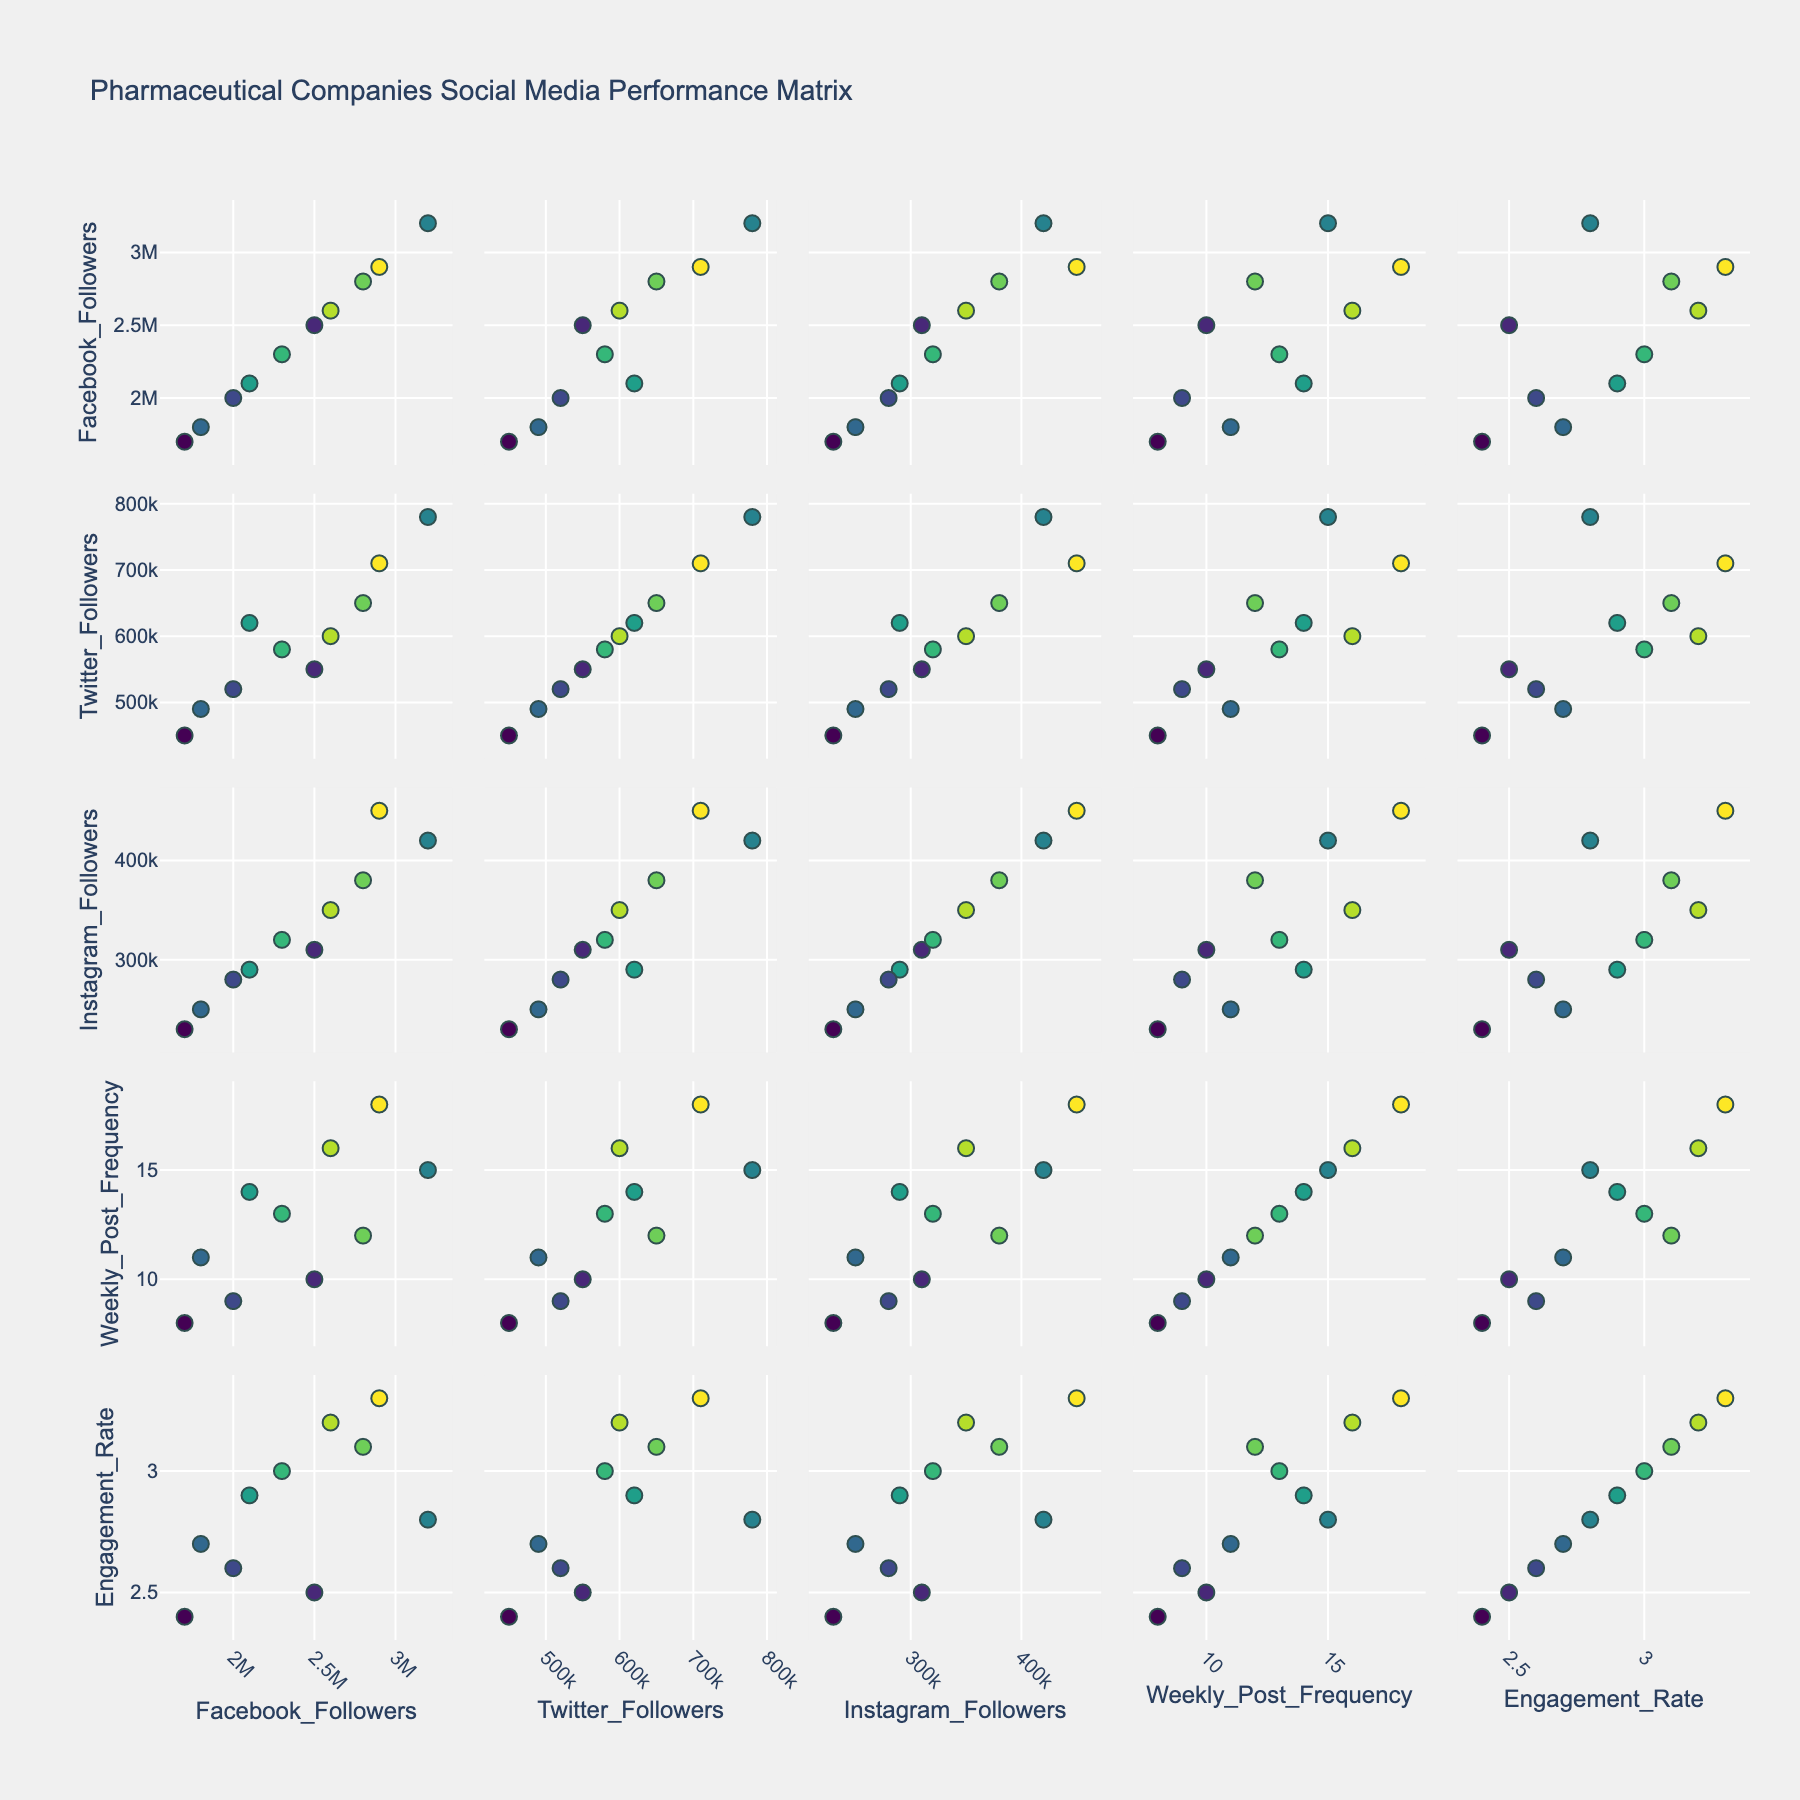What is the title of the figure? The title of the figure is usually located at the center-top of the plot. By observing this area, we can read the title.
Answer: Pharmaceutical Companies Social Media Performance Matrix How many companies are represented in the scatterplot matrix? Count the number of distinct companies plotted. Each company's data is represented by a unique color point in the matrix, hence counting these points will give the number of companies.
Answer: 10 Which company has the highest engagement rate? Look for the point with the highest value on the "Engagement Rate" axis and note the corresponding company label.
Answer: Johnson & Johnson What is the relationship between Weekly Post Frequency and Engagement Rate for Pfizer? Locate the row-Engagement Rate and column-Weekly Post Frequency plot, find the data point labeled Pfizer, and observe its positioning.
Answer: Generally positive Does AstraZeneca have more Facebook followers than Eli Lilly? Find the Facebook Followers vs. Company scatterplot, locate AstraZeneca and Eli Lilly points, and compare their positions on the horizontal axis.
Answer: Yes How do Twitter followers correlate with Instagram followers? Look at the Twitter Followers vs. Instagram Followers scatterplot and observe the overall trend of the points.
Answer: Generally positive Which company posts the most frequently per week? Identify the company with the highest value in the Weekly Post Frequency axis.
Answer: Johnson & Johnson Do companies with higher Weekly Post Frequency generally have higher engagement rates? Look at the Weekly Post Frequency vs. Engagement Rate plot and note the general trend of the points.
Answer: Generally positive trend Between Roche and GlaxoSmithKline, which company has a higher Instagram follower count? Find the Instagram Followers vs. Company scatterplot and compare the horizontal positions of Roche and GlaxoSmithKline.
Answer: GlaxoSmithKline Is there any company with both high Weekly Post Frequency and low Engagement Rate? Scan the Weekly Post Frequency vs. Engagement Rate plot to identify points with high x-values (Weekly Post Frequency) and low y-values (Engagement Rate).
Answer: No, all companies with high frequency also have moderate to high engagement rates 